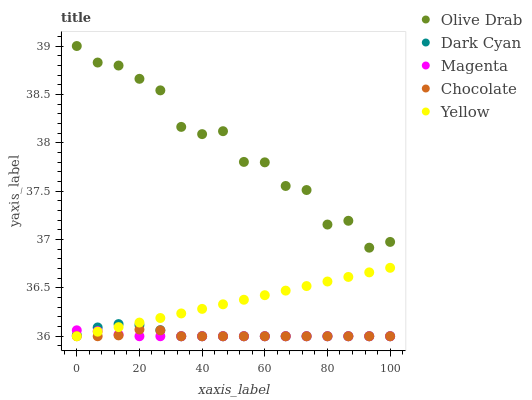Does Magenta have the minimum area under the curve?
Answer yes or no. Yes. Does Olive Drab have the maximum area under the curve?
Answer yes or no. Yes. Does Yellow have the minimum area under the curve?
Answer yes or no. No. Does Yellow have the maximum area under the curve?
Answer yes or no. No. Is Yellow the smoothest?
Answer yes or no. Yes. Is Olive Drab the roughest?
Answer yes or no. Yes. Is Magenta the smoothest?
Answer yes or no. No. Is Magenta the roughest?
Answer yes or no. No. Does Dark Cyan have the lowest value?
Answer yes or no. Yes. Does Olive Drab have the lowest value?
Answer yes or no. No. Does Olive Drab have the highest value?
Answer yes or no. Yes. Does Yellow have the highest value?
Answer yes or no. No. Is Dark Cyan less than Olive Drab?
Answer yes or no. Yes. Is Olive Drab greater than Magenta?
Answer yes or no. Yes. Does Chocolate intersect Yellow?
Answer yes or no. Yes. Is Chocolate less than Yellow?
Answer yes or no. No. Is Chocolate greater than Yellow?
Answer yes or no. No. Does Dark Cyan intersect Olive Drab?
Answer yes or no. No. 